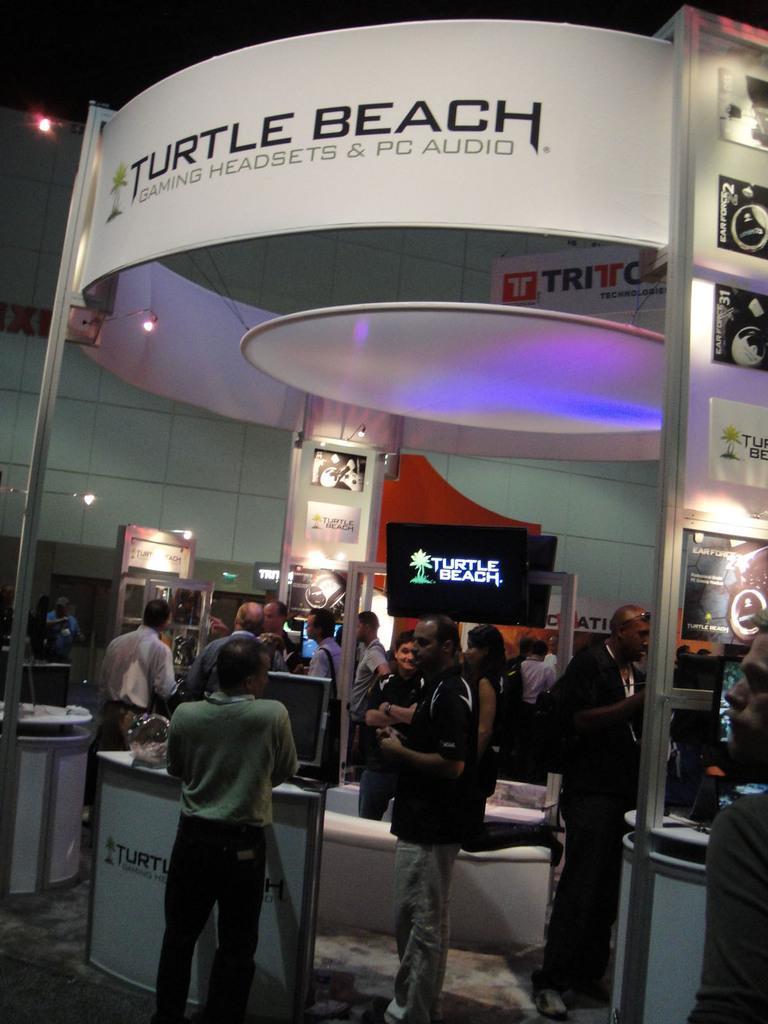Describe this image in one or two sentences. In this picture we can see there are groups of people standing. In front of the people there are televisions, boards, lights and some objects. 